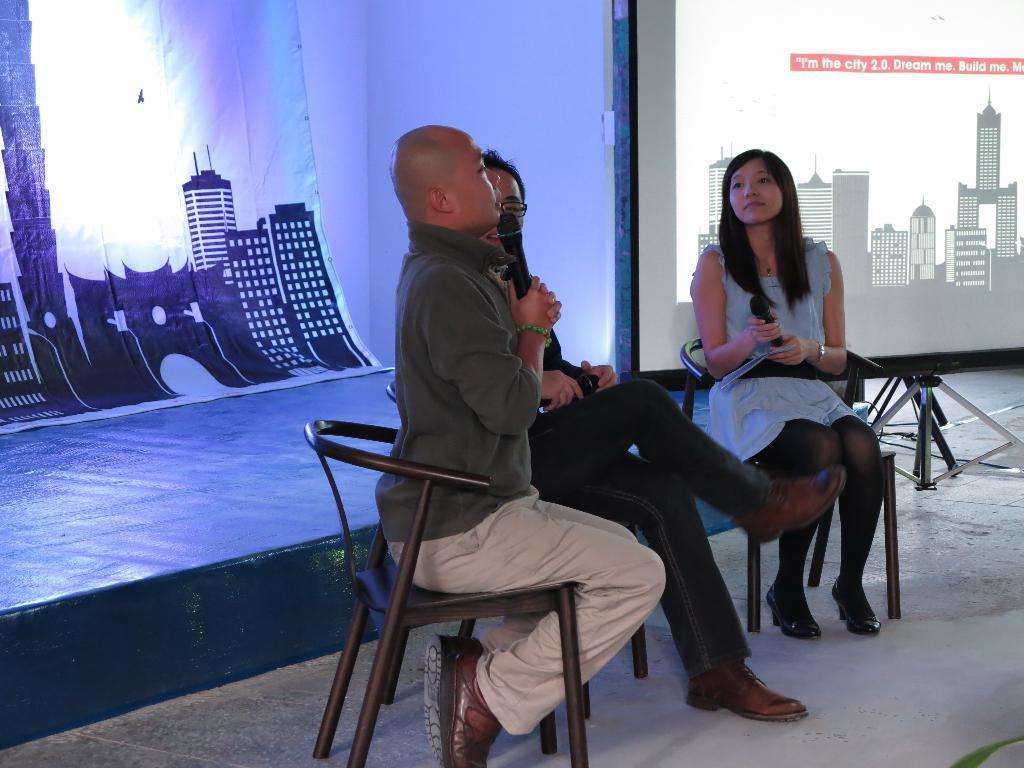How would you summarize this image in a sentence or two? This 3 persons are sitting on a chair. This 2 persons are holding a mic. This is a stage with poster. This is a screen with buildings. 